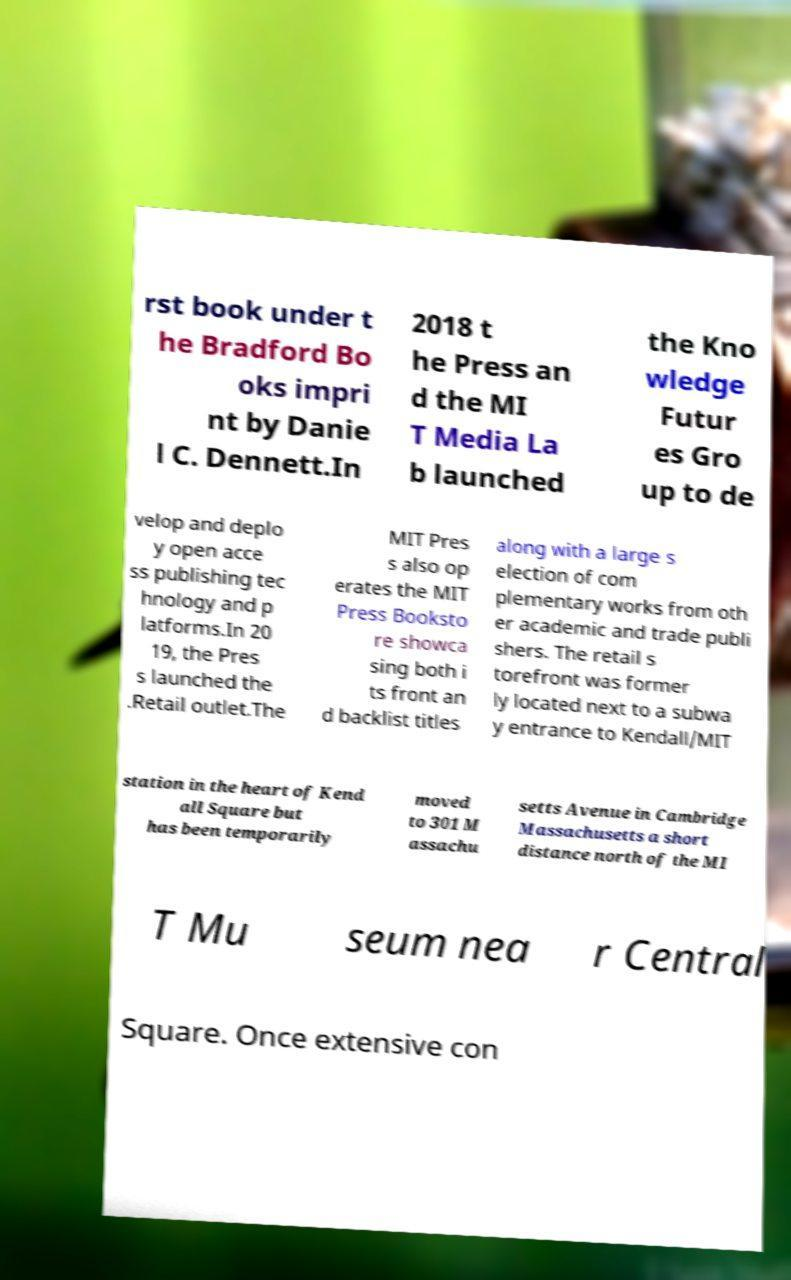For documentation purposes, I need the text within this image transcribed. Could you provide that? rst book under t he Bradford Bo oks impri nt by Danie l C. Dennett.In 2018 t he Press an d the MI T Media La b launched the Kno wledge Futur es Gro up to de velop and deplo y open acce ss publishing tec hnology and p latforms.In 20 19, the Pres s launched the .Retail outlet.The MIT Pres s also op erates the MIT Press Booksto re showca sing both i ts front an d backlist titles along with a large s election of com plementary works from oth er academic and trade publi shers. The retail s torefront was former ly located next to a subwa y entrance to Kendall/MIT station in the heart of Kend all Square but has been temporarily moved to 301 M assachu setts Avenue in Cambridge Massachusetts a short distance north of the MI T Mu seum nea r Central Square. Once extensive con 